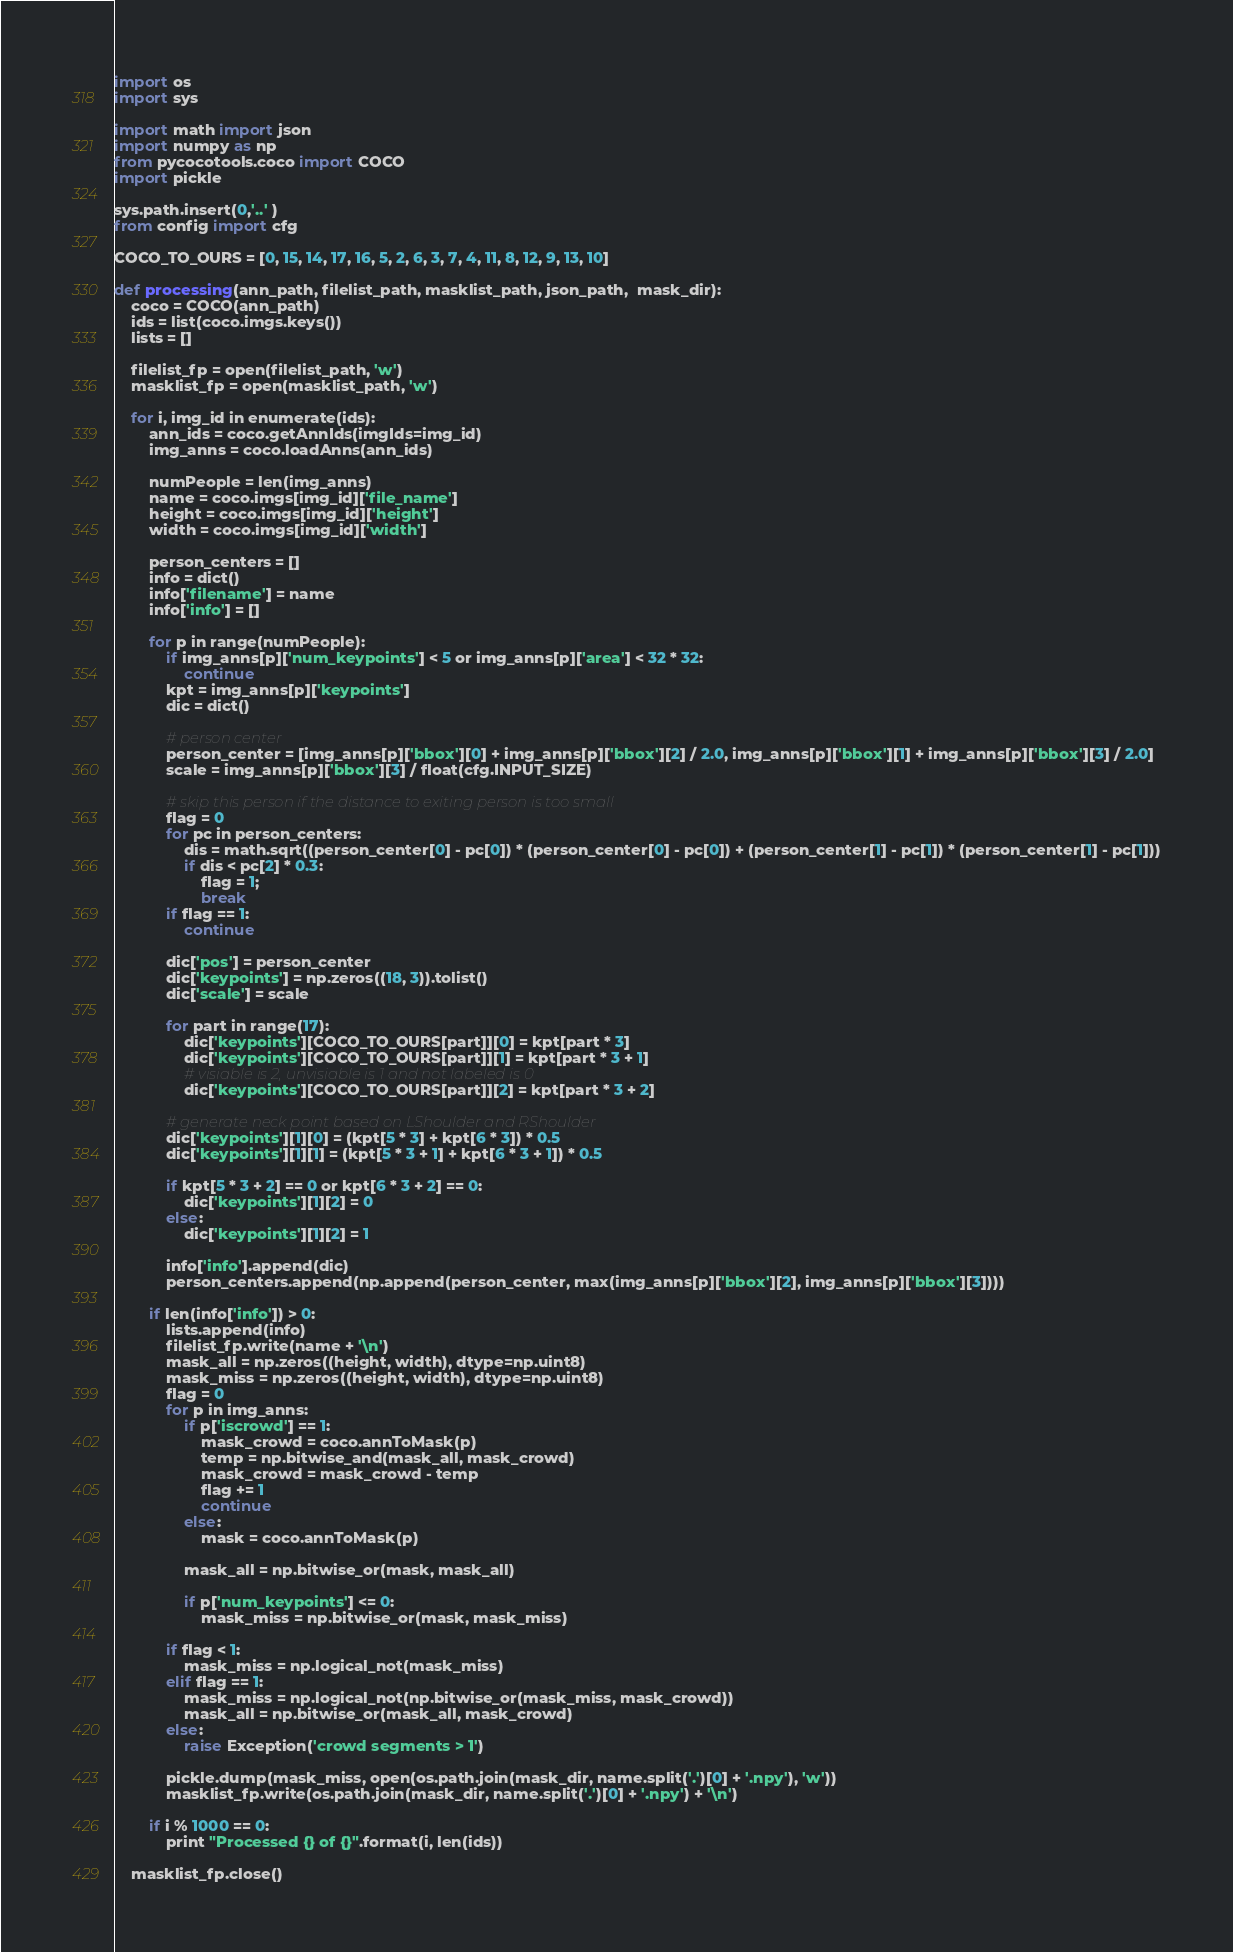Convert code to text. <code><loc_0><loc_0><loc_500><loc_500><_Python_>import os
import sys

import math import json
import numpy as np
from pycocotools.coco import COCO
import pickle

sys.path.insert(0,'..' )
from config import cfg

COCO_TO_OURS = [0, 15, 14, 17, 16, 5, 2, 6, 3, 7, 4, 11, 8, 12, 9, 13, 10]

def processing(ann_path, filelist_path, masklist_path, json_path,  mask_dir):
    coco = COCO(ann_path)
    ids = list(coco.imgs.keys())
    lists = []
    
    filelist_fp = open(filelist_path, 'w')
    masklist_fp = open(masklist_path, 'w')
    
    for i, img_id in enumerate(ids):
        ann_ids = coco.getAnnIds(imgIds=img_id)
        img_anns = coco.loadAnns(ann_ids)
    
        numPeople = len(img_anns)
        name = coco.imgs[img_id]['file_name']
        height = coco.imgs[img_id]['height']
        width = coco.imgs[img_id]['width']
    
        person_centers = []
        info = dict()
        info['filename'] = name
        info['info'] = []
    
        for p in range(numPeople):
            if img_anns[p]['num_keypoints'] < 5 or img_anns[p]['area'] < 32 * 32:
                continue
            kpt = img_anns[p]['keypoints']
            dic = dict()
    
            # person center
            person_center = [img_anns[p]['bbox'][0] + img_anns[p]['bbox'][2] / 2.0, img_anns[p]['bbox'][1] + img_anns[p]['bbox'][3] / 2.0]
            scale = img_anns[p]['bbox'][3] / float(cfg.INPUT_SIZE)
    
            # skip this person if the distance to exiting person is too small
            flag = 0
            for pc in person_centers:
                dis = math.sqrt((person_center[0] - pc[0]) * (person_center[0] - pc[0]) + (person_center[1] - pc[1]) * (person_center[1] - pc[1]))
                if dis < pc[2] * 0.3:
                    flag = 1;
                    break
            if flag == 1:
                continue

            dic['pos'] = person_center
            dic['keypoints'] = np.zeros((18, 3)).tolist()
            dic['scale'] = scale

            for part in range(17):
                dic['keypoints'][COCO_TO_OURS[part]][0] = kpt[part * 3]
                dic['keypoints'][COCO_TO_OURS[part]][1] = kpt[part * 3 + 1]
                # visiable is 2, unvisiable is 1 and not labeled is 0
                dic['keypoints'][COCO_TO_OURS[part]][2] = kpt[part * 3 + 2]
            
            # generate neck point based on LShoulder and RShoulder
            dic['keypoints'][1][0] = (kpt[5 * 3] + kpt[6 * 3]) * 0.5
            dic['keypoints'][1][1] = (kpt[5 * 3 + 1] + kpt[6 * 3 + 1]) * 0.5

            if kpt[5 * 3 + 2] == 0 or kpt[6 * 3 + 2] == 0:
                dic['keypoints'][1][2] = 0
            else:
                dic['keypoints'][1][2] = 1

            info['info'].append(dic)
            person_centers.append(np.append(person_center, max(img_anns[p]['bbox'][2], img_anns[p]['bbox'][3])))

        if len(info['info']) > 0:
            lists.append(info)
            filelist_fp.write(name + '\n')
            mask_all = np.zeros((height, width), dtype=np.uint8)
            mask_miss = np.zeros((height, width), dtype=np.uint8)
            flag = 0
            for p in img_anns:
                if p['iscrowd'] == 1:
                    mask_crowd = coco.annToMask(p)
                    temp = np.bitwise_and(mask_all, mask_crowd)
                    mask_crowd = mask_crowd - temp
                    flag += 1
                    continue
                else:
                    mask = coco.annToMask(p)
        
                mask_all = np.bitwise_or(mask, mask_all)
            
                if p['num_keypoints'] <= 0:
                    mask_miss = np.bitwise_or(mask, mask_miss)
        
            if flag < 1:
                mask_miss = np.logical_not(mask_miss)
            elif flag == 1:
                mask_miss = np.logical_not(np.bitwise_or(mask_miss, mask_crowd))
                mask_all = np.bitwise_or(mask_all, mask_crowd)
            else:
                raise Exception('crowd segments > 1')
            
            pickle.dump(mask_miss, open(os.path.join(mask_dir, name.split('.')[0] + '.npy'), 'w'))
            masklist_fp.write(os.path.join(mask_dir, name.split('.')[0] + '.npy') + '\n')

        if i % 1000 == 0:
            print "Processed {} of {}".format(i, len(ids))
    
    masklist_fp.close()</code> 